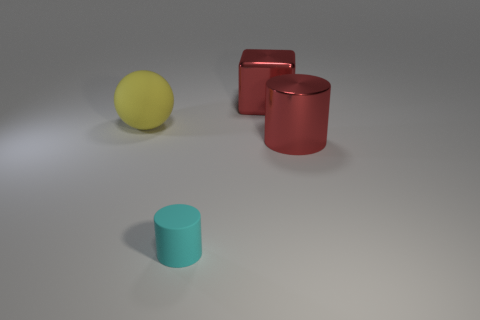Add 3 red cubes. How many objects exist? 7 Subtract 0 purple blocks. How many objects are left? 4 Subtract all cubes. How many objects are left? 3 Subtract all purple cylinders. Subtract all blue spheres. How many cylinders are left? 2 Subtract all yellow blocks. How many red cylinders are left? 1 Subtract all shiny cylinders. Subtract all yellow balls. How many objects are left? 2 Add 2 big yellow objects. How many big yellow objects are left? 3 Add 1 tiny brown blocks. How many tiny brown blocks exist? 1 